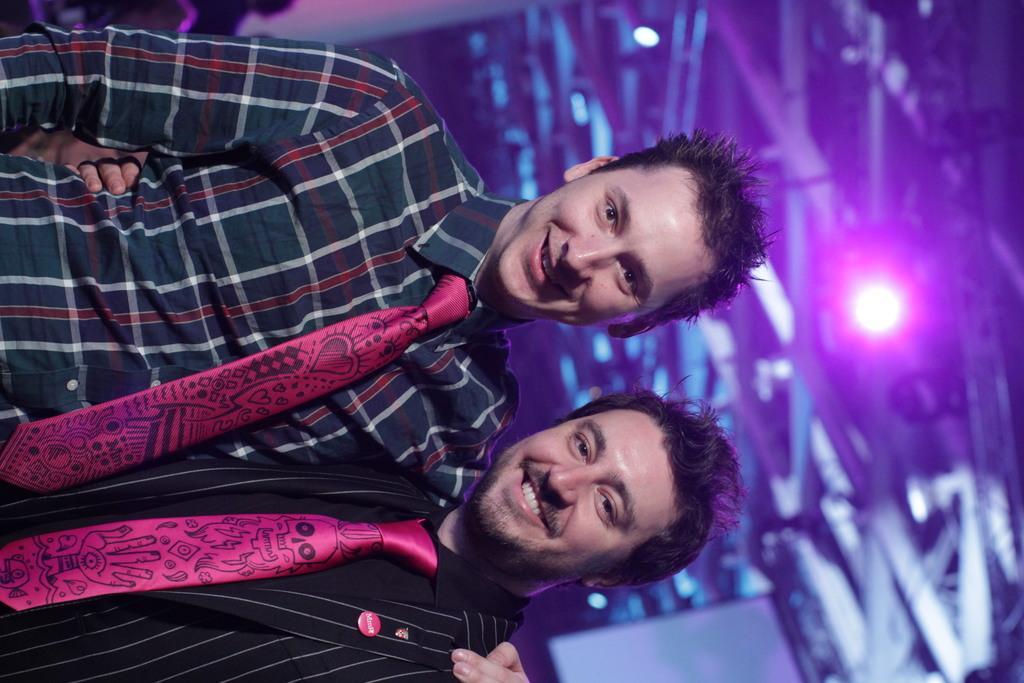Please provide a concise description of this image. This picture seems to be clicked inside. On the left there is a person wearing shirt, tie, smiling and standing, beside him there is another person wearing suit, pink color tie, smiling and standing. In the background we can see the metal rods, the focusing lights and some other items. 